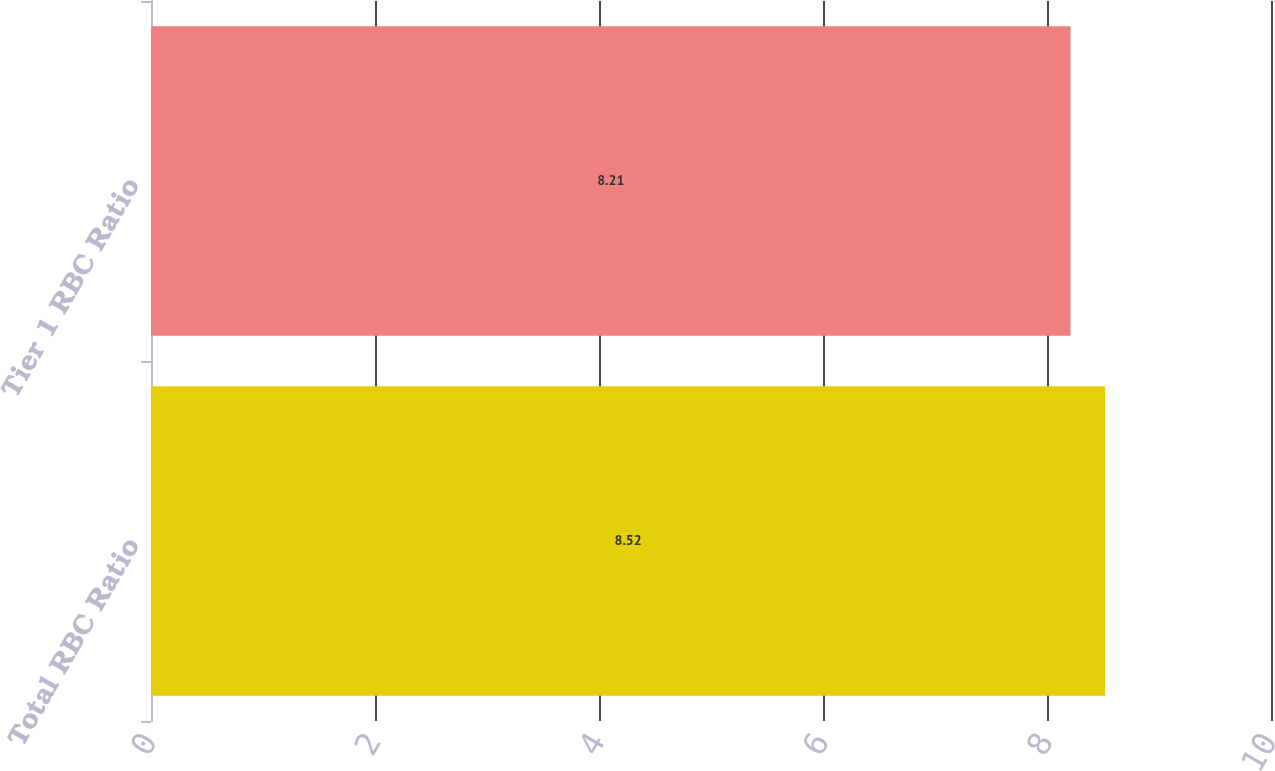Convert chart. <chart><loc_0><loc_0><loc_500><loc_500><bar_chart><fcel>Total RBC Ratio<fcel>Tier 1 RBC Ratio<nl><fcel>8.52<fcel>8.21<nl></chart> 